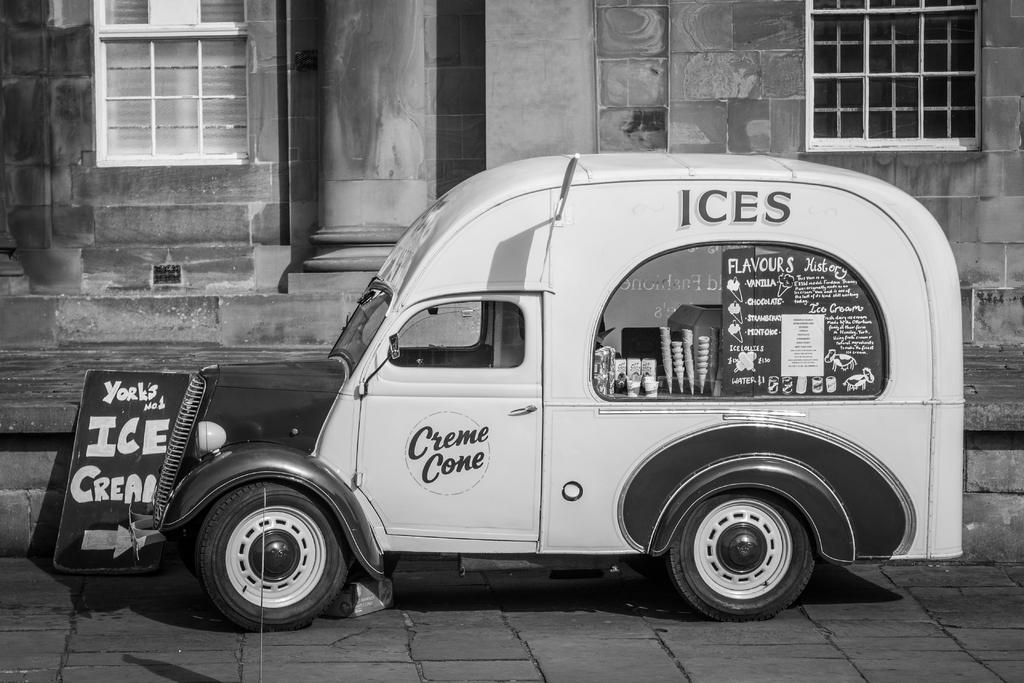What is the main subject in the foreground of the image? There is a van in the foreground of the image. What is the color scheme of the image? The image is black and white. What can be seen in the background of the image? There is a board and a building in the background of the image. What type of ornament is hanging from the van in the image? There is no ornament hanging from the van in the image. Is there a sofa visible in the background of the image? There is no sofa present in the image. 